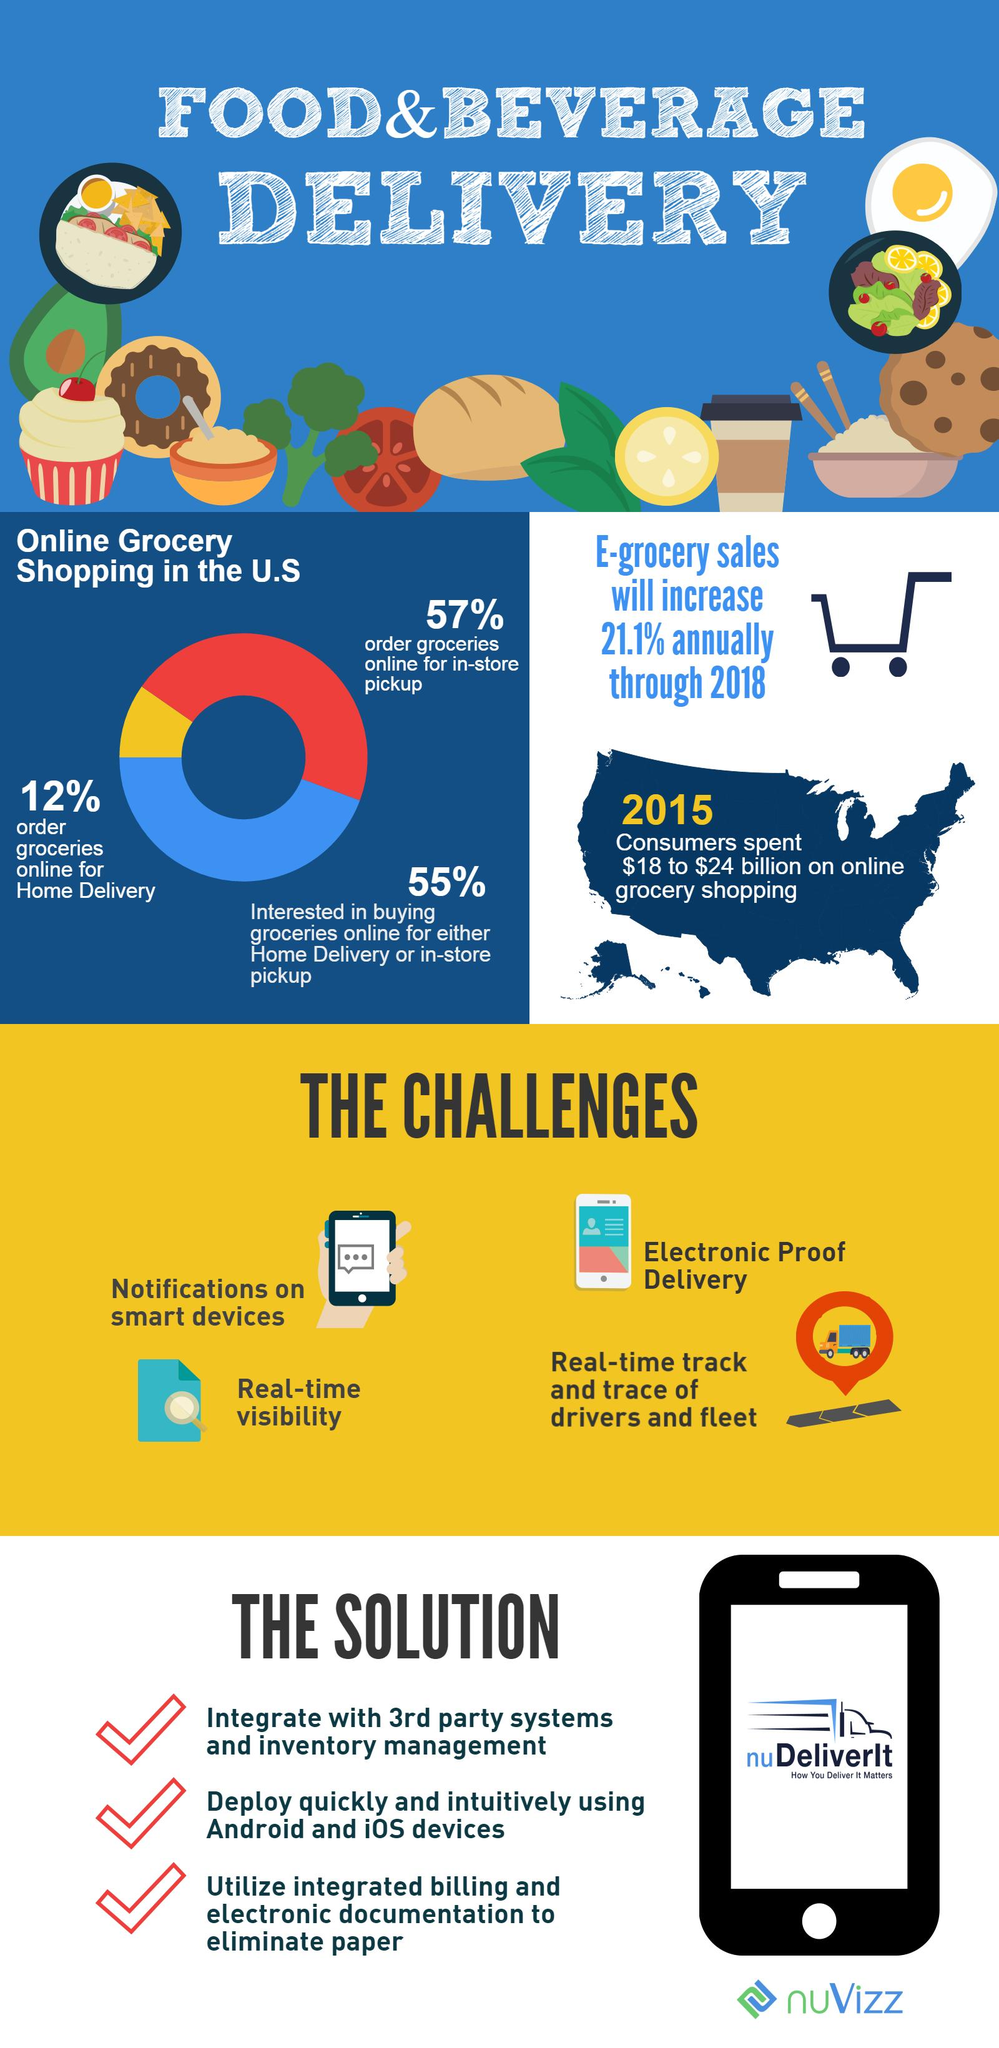Point out several critical features in this image. According to a recent survey, the most popular platform for online grocery shopping in the United States is [insert name], with the highest share of customers interested in purchasing groceries online for either home delivery or in-store pickup. 